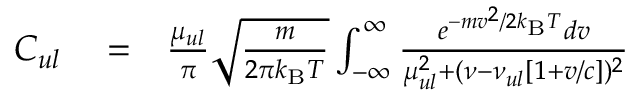Convert formula to latex. <formula><loc_0><loc_0><loc_500><loc_500>\begin{array} { r l r } { C _ { u l } } & = } & { \frac { \mu _ { u l } } { \pi } \sqrt { \frac { m } { 2 \pi k _ { B } T } } \int _ { - \infty } ^ { \infty } \frac { e ^ { - m v ^ { 2 } / 2 k _ { B } T } d v } { \mu _ { u l } ^ { 2 } + ( \nu - \nu _ { u l } [ 1 + v / c ] ) ^ { 2 } } } \end{array}</formula> 